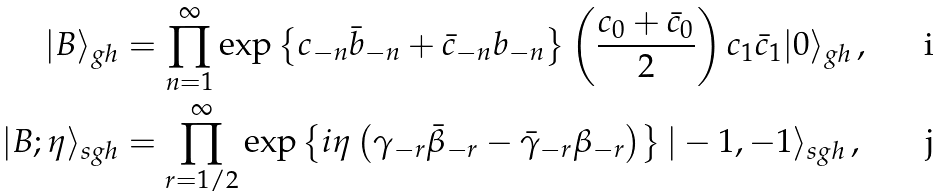Convert formula to latex. <formula><loc_0><loc_0><loc_500><loc_500>| B \rangle _ { g h } & = \prod _ { n = 1 } ^ { \infty } \exp \left \{ c _ { - n } \bar { b } _ { - n } + \bar { c } _ { - n } b _ { - n } \right \} \left ( \frac { c _ { 0 } + \bar { c } _ { 0 } } { 2 } \right ) c _ { 1 } \bar { c } _ { 1 } | 0 \rangle _ { g h } \, , \\ | B ; \eta \rangle _ { s g h } & = \prod _ { r = 1 / 2 } ^ { \infty } \exp \left \{ i \eta \left ( \gamma _ { - r } \bar { \beta } _ { - r } - \bar { \gamma } _ { - r } \beta _ { - r } \right ) \right \} | - 1 , - 1 \rangle _ { s g h } \, ,</formula> 